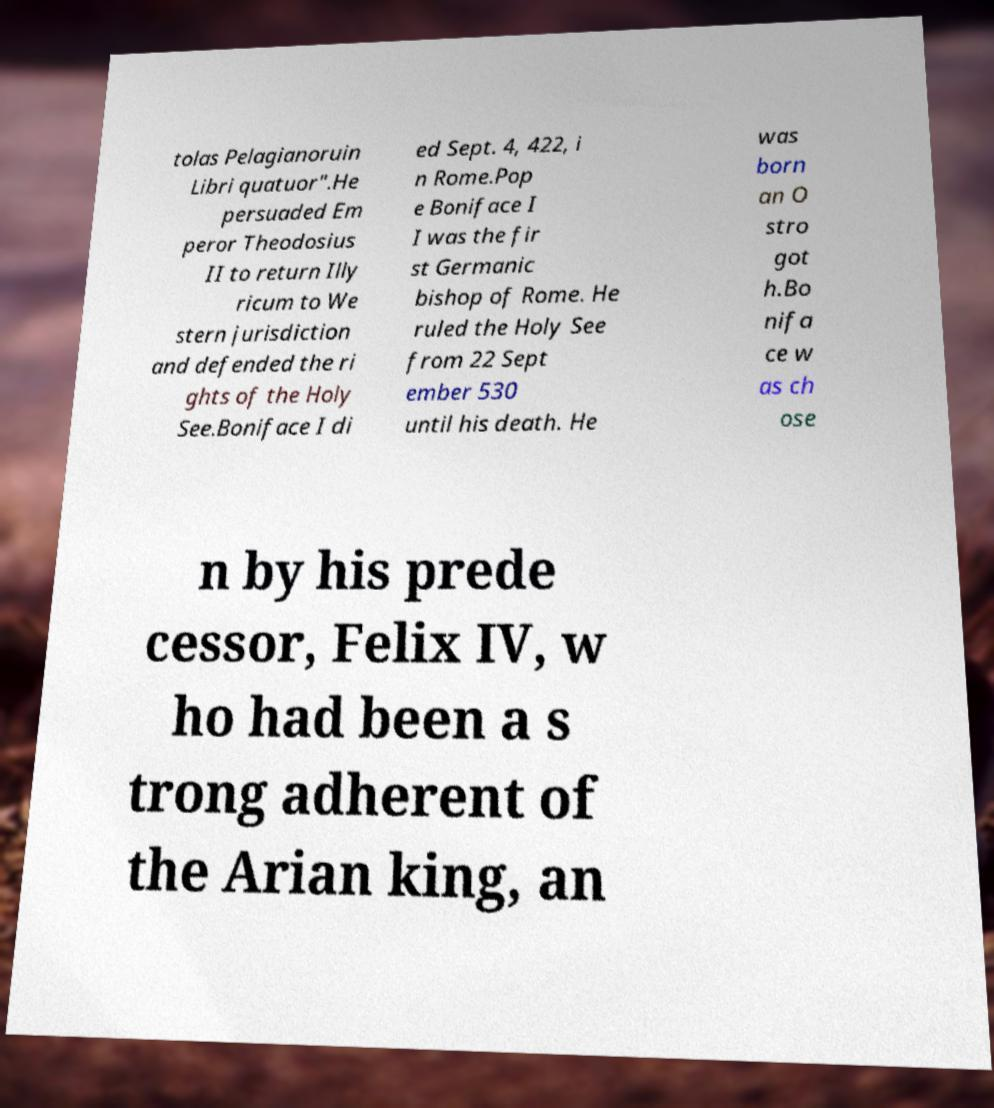Could you extract and type out the text from this image? tolas Pelagianoruin Libri quatuor".He persuaded Em peror Theodosius II to return Illy ricum to We stern jurisdiction and defended the ri ghts of the Holy See.Boniface I di ed Sept. 4, 422, i n Rome.Pop e Boniface I I was the fir st Germanic bishop of Rome. He ruled the Holy See from 22 Sept ember 530 until his death. He was born an O stro got h.Bo nifa ce w as ch ose n by his prede cessor, Felix IV, w ho had been a s trong adherent of the Arian king, an 